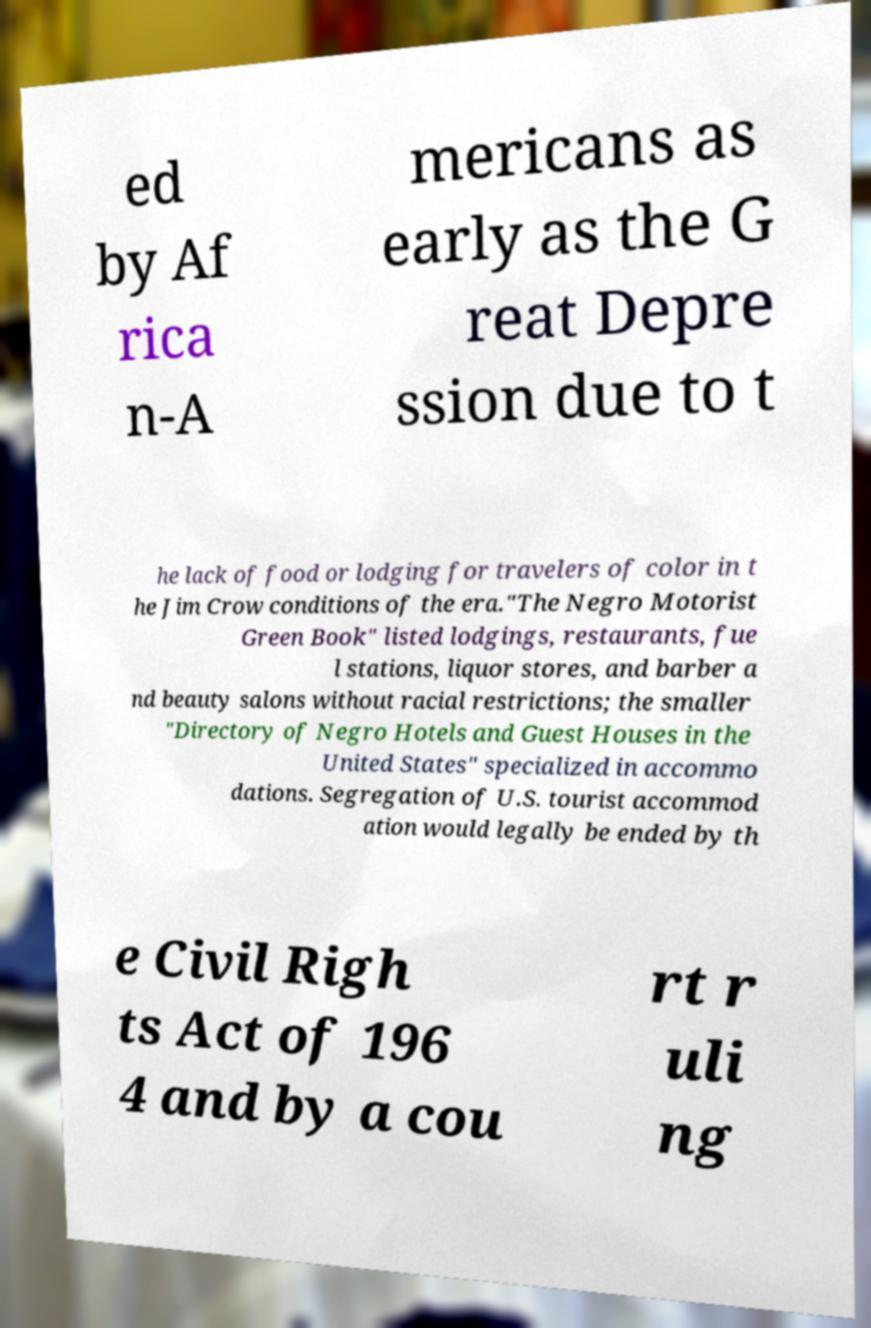Please read and relay the text visible in this image. What does it say? ed by Af rica n-A mericans as early as the G reat Depre ssion due to t he lack of food or lodging for travelers of color in t he Jim Crow conditions of the era."The Negro Motorist Green Book" listed lodgings, restaurants, fue l stations, liquor stores, and barber a nd beauty salons without racial restrictions; the smaller "Directory of Negro Hotels and Guest Houses in the United States" specialized in accommo dations. Segregation of U.S. tourist accommod ation would legally be ended by th e Civil Righ ts Act of 196 4 and by a cou rt r uli ng 